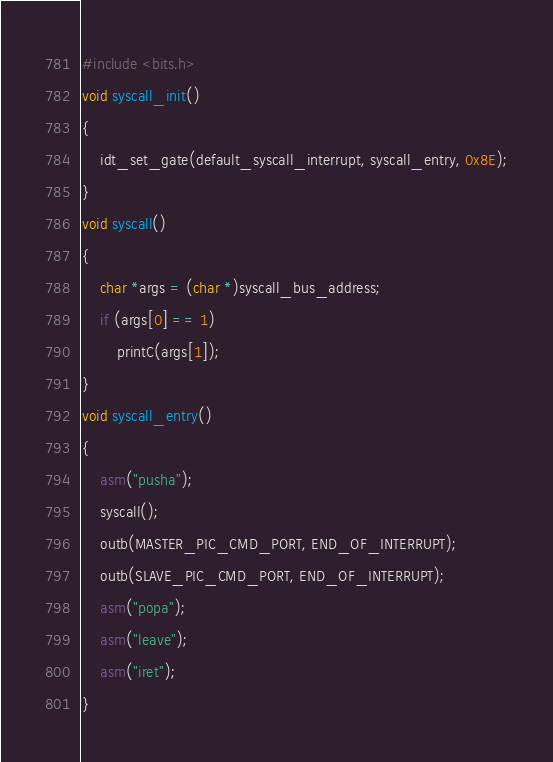Convert code to text. <code><loc_0><loc_0><loc_500><loc_500><_C_>#include <bits.h>
void syscall_init()
{
	idt_set_gate(default_syscall_interrupt, syscall_entry, 0x8E);
}
void syscall()
{
	char *args = (char *)syscall_bus_address;
	if (args[0] == 1)
		printC(args[1]);
}
void syscall_entry()
{
	asm("pusha");
	syscall();
	outb(MASTER_PIC_CMD_PORT, END_OF_INTERRUPT);
	outb(SLAVE_PIC_CMD_PORT, END_OF_INTERRUPT);
	asm("popa");
	asm("leave");
	asm("iret");
}</code> 